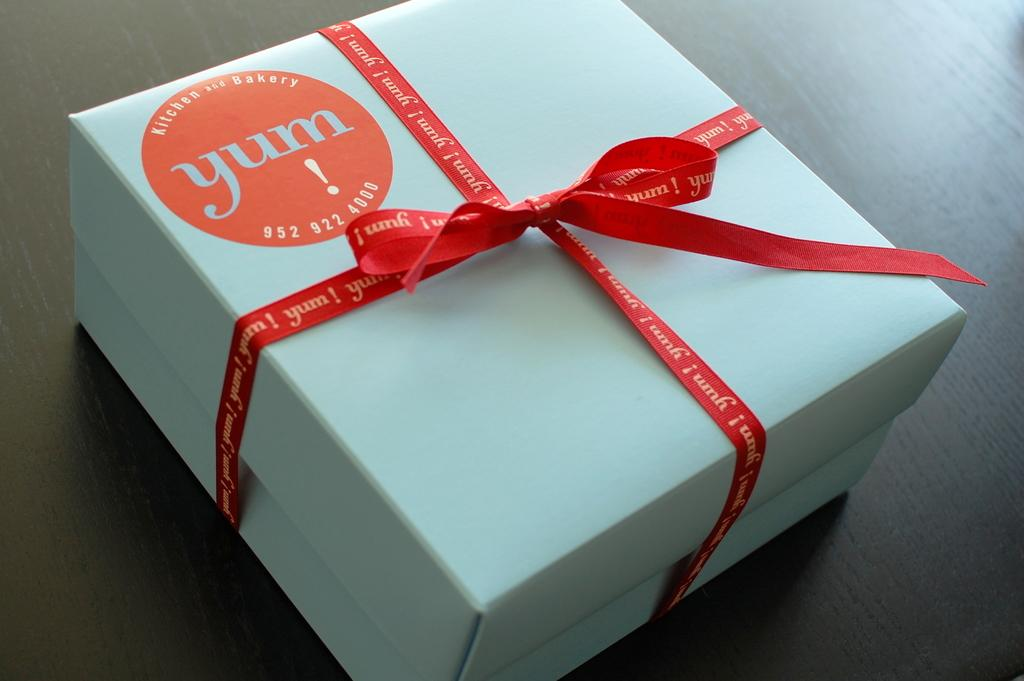<image>
Present a compact description of the photo's key features. A white box tied with a red ribbon has a Yum Kitchen and Bakery sticker on it. 